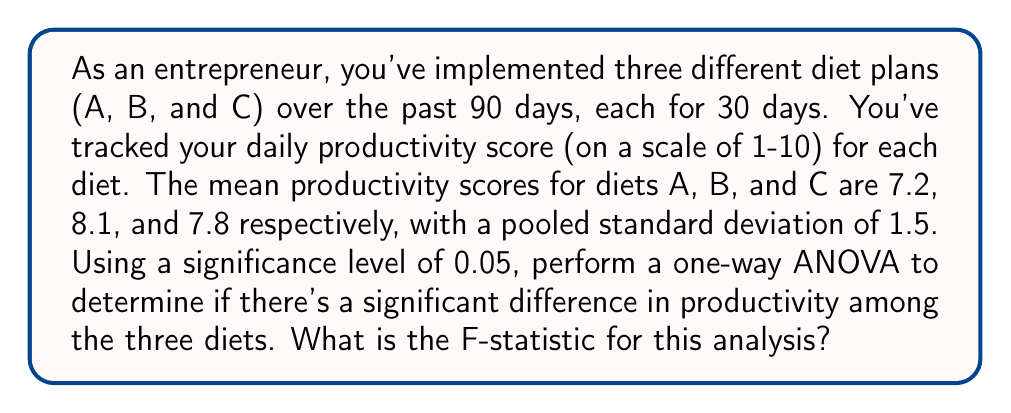Show me your answer to this math problem. To perform a one-way ANOVA, we need to calculate the F-statistic. The steps are as follows:

1. Calculate the between-group variance:
   $$SS_{between} = \sum_{i=1}^k n_i(\bar{x}_i - \bar{x})^2$$
   where $k$ is the number of groups, $n_i$ is the sample size of each group, $\bar{x}_i$ is the mean of each group, and $\bar{x}$ is the grand mean.

2. Calculate the within-group variance:
   $$SS_{within} = (N - k)s_p^2$$
   where $N$ is the total sample size, $k$ is the number of groups, and $s_p^2$ is the pooled variance.

3. Calculate the degrees of freedom:
   $$df_{between} = k - 1$$
   $$df_{within} = N - k$$

4. Calculate the mean square between and within:
   $$MS_{between} = \frac{SS_{between}}{df_{between}}$$
   $$MS_{within} = \frac{SS_{within}}{df_{within}}$$

5. Calculate the F-statistic:
   $$F = \frac{MS_{between}}{MS_{within}}$$

Now, let's apply these steps to our problem:

1. Grand mean: $\bar{x} = \frac{7.2 + 8.1 + 7.8}{3} = 7.7$

2. $SS_{between} = 30(7.2 - 7.7)^2 + 30(8.1 - 7.7)^2 + 30(7.8 - 7.7)^2 = 11.7$

3. $SS_{within} = (90 - 3) * 1.5^2 = 195.75$

4. $df_{between} = 3 - 1 = 2$
   $df_{within} = 90 - 3 = 87$

5. $MS_{between} = \frac{11.7}{2} = 5.85$
   $MS_{within} = \frac{195.75}{87} = 2.25$

6. $F = \frac{5.85}{2.25} = 2.6$
Answer: The F-statistic for this analysis is 2.6. 